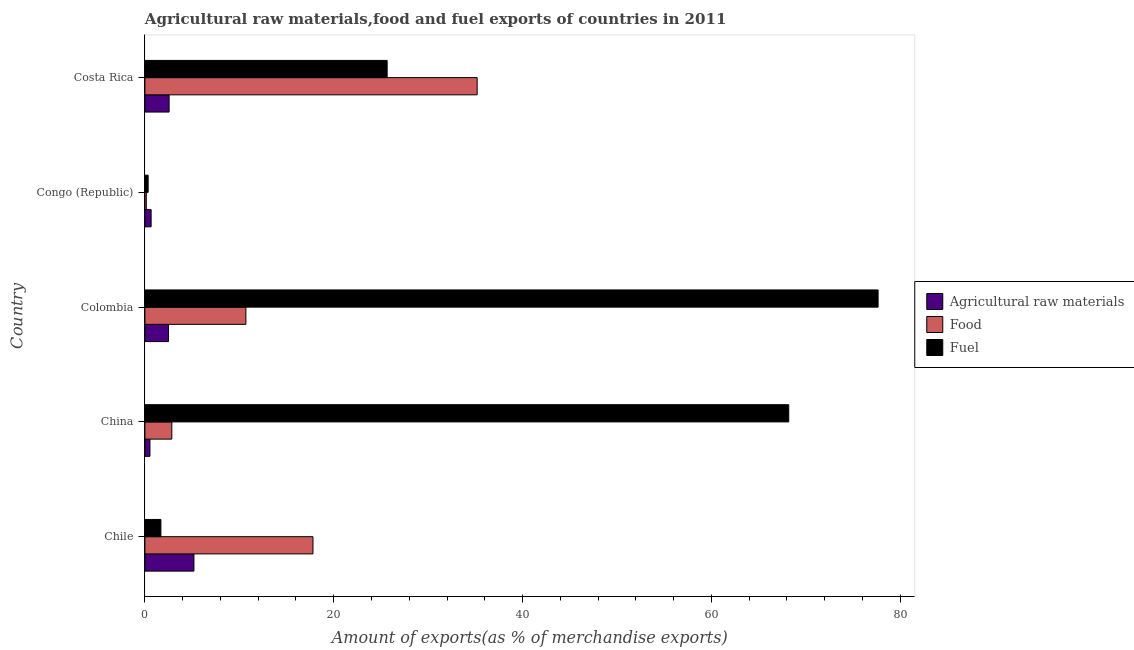How many groups of bars are there?
Ensure brevity in your answer.  5. Are the number of bars on each tick of the Y-axis equal?
Offer a terse response. Yes. How many bars are there on the 5th tick from the top?
Offer a terse response. 3. What is the label of the 1st group of bars from the top?
Ensure brevity in your answer.  Costa Rica. In how many cases, is the number of bars for a given country not equal to the number of legend labels?
Your answer should be very brief. 0. What is the percentage of raw materials exports in Costa Rica?
Keep it short and to the point. 2.56. Across all countries, what is the maximum percentage of fuel exports?
Your response must be concise. 77.67. Across all countries, what is the minimum percentage of fuel exports?
Your response must be concise. 0.34. In which country was the percentage of food exports minimum?
Make the answer very short. Congo (Republic). What is the total percentage of food exports in the graph?
Make the answer very short. 66.69. What is the difference between the percentage of raw materials exports in Chile and that in Congo (Republic)?
Offer a very short reply. 4.53. What is the difference between the percentage of fuel exports in Costa Rica and the percentage of raw materials exports in Chile?
Give a very brief answer. 20.47. What is the average percentage of fuel exports per country?
Give a very brief answer. 34.71. What is the difference between the percentage of fuel exports and percentage of raw materials exports in China?
Keep it short and to the point. 67.67. In how many countries, is the percentage of raw materials exports greater than 60 %?
Offer a very short reply. 0. What is the ratio of the percentage of raw materials exports in China to that in Congo (Republic)?
Your answer should be very brief. 0.81. Is the percentage of raw materials exports in Chile less than that in China?
Offer a terse response. No. Is the difference between the percentage of fuel exports in Chile and China greater than the difference between the percentage of food exports in Chile and China?
Provide a succinct answer. No. What is the difference between the highest and the second highest percentage of food exports?
Your answer should be compact. 17.39. What is the difference between the highest and the lowest percentage of raw materials exports?
Your response must be concise. 4.66. In how many countries, is the percentage of fuel exports greater than the average percentage of fuel exports taken over all countries?
Give a very brief answer. 2. Is the sum of the percentage of raw materials exports in Colombia and Costa Rica greater than the maximum percentage of fuel exports across all countries?
Your answer should be compact. No. What does the 3rd bar from the top in Chile represents?
Provide a short and direct response. Agricultural raw materials. What does the 2nd bar from the bottom in Colombia represents?
Offer a terse response. Food. Is it the case that in every country, the sum of the percentage of raw materials exports and percentage of food exports is greater than the percentage of fuel exports?
Make the answer very short. No. How many bars are there?
Ensure brevity in your answer.  15. How many countries are there in the graph?
Your response must be concise. 5. What is the difference between two consecutive major ticks on the X-axis?
Offer a very short reply. 20. Does the graph contain grids?
Keep it short and to the point. No. Where does the legend appear in the graph?
Give a very brief answer. Center right. How are the legend labels stacked?
Keep it short and to the point. Vertical. What is the title of the graph?
Provide a short and direct response. Agricultural raw materials,food and fuel exports of countries in 2011. What is the label or title of the X-axis?
Provide a short and direct response. Amount of exports(as % of merchandise exports). What is the label or title of the Y-axis?
Make the answer very short. Country. What is the Amount of exports(as % of merchandise exports) of Agricultural raw materials in Chile?
Provide a succinct answer. 5.19. What is the Amount of exports(as % of merchandise exports) of Food in Chile?
Keep it short and to the point. 17.8. What is the Amount of exports(as % of merchandise exports) in Fuel in Chile?
Ensure brevity in your answer.  1.69. What is the Amount of exports(as % of merchandise exports) of Agricultural raw materials in China?
Keep it short and to the point. 0.53. What is the Amount of exports(as % of merchandise exports) of Food in China?
Provide a succinct answer. 2.85. What is the Amount of exports(as % of merchandise exports) of Fuel in China?
Provide a succinct answer. 68.2. What is the Amount of exports(as % of merchandise exports) in Agricultural raw materials in Colombia?
Provide a short and direct response. 2.5. What is the Amount of exports(as % of merchandise exports) of Food in Colombia?
Your response must be concise. 10.7. What is the Amount of exports(as % of merchandise exports) of Fuel in Colombia?
Offer a very short reply. 77.67. What is the Amount of exports(as % of merchandise exports) of Agricultural raw materials in Congo (Republic)?
Ensure brevity in your answer.  0.66. What is the Amount of exports(as % of merchandise exports) in Food in Congo (Republic)?
Offer a very short reply. 0.15. What is the Amount of exports(as % of merchandise exports) in Fuel in Congo (Republic)?
Your response must be concise. 0.34. What is the Amount of exports(as % of merchandise exports) of Agricultural raw materials in Costa Rica?
Make the answer very short. 2.56. What is the Amount of exports(as % of merchandise exports) in Food in Costa Rica?
Offer a terse response. 35.19. What is the Amount of exports(as % of merchandise exports) of Fuel in Costa Rica?
Offer a very short reply. 25.66. Across all countries, what is the maximum Amount of exports(as % of merchandise exports) of Agricultural raw materials?
Ensure brevity in your answer.  5.19. Across all countries, what is the maximum Amount of exports(as % of merchandise exports) of Food?
Your answer should be compact. 35.19. Across all countries, what is the maximum Amount of exports(as % of merchandise exports) of Fuel?
Keep it short and to the point. 77.67. Across all countries, what is the minimum Amount of exports(as % of merchandise exports) in Agricultural raw materials?
Keep it short and to the point. 0.53. Across all countries, what is the minimum Amount of exports(as % of merchandise exports) in Food?
Make the answer very short. 0.15. Across all countries, what is the minimum Amount of exports(as % of merchandise exports) of Fuel?
Provide a short and direct response. 0.34. What is the total Amount of exports(as % of merchandise exports) in Agricultural raw materials in the graph?
Offer a very short reply. 11.45. What is the total Amount of exports(as % of merchandise exports) of Food in the graph?
Your response must be concise. 66.69. What is the total Amount of exports(as % of merchandise exports) in Fuel in the graph?
Your answer should be very brief. 173.56. What is the difference between the Amount of exports(as % of merchandise exports) in Agricultural raw materials in Chile and that in China?
Keep it short and to the point. 4.66. What is the difference between the Amount of exports(as % of merchandise exports) of Food in Chile and that in China?
Provide a succinct answer. 14.95. What is the difference between the Amount of exports(as % of merchandise exports) in Fuel in Chile and that in China?
Ensure brevity in your answer.  -66.51. What is the difference between the Amount of exports(as % of merchandise exports) of Agricultural raw materials in Chile and that in Colombia?
Ensure brevity in your answer.  2.69. What is the difference between the Amount of exports(as % of merchandise exports) of Food in Chile and that in Colombia?
Your answer should be very brief. 7.11. What is the difference between the Amount of exports(as % of merchandise exports) in Fuel in Chile and that in Colombia?
Your response must be concise. -75.97. What is the difference between the Amount of exports(as % of merchandise exports) in Agricultural raw materials in Chile and that in Congo (Republic)?
Offer a very short reply. 4.53. What is the difference between the Amount of exports(as % of merchandise exports) in Food in Chile and that in Congo (Republic)?
Give a very brief answer. 17.65. What is the difference between the Amount of exports(as % of merchandise exports) in Fuel in Chile and that in Congo (Republic)?
Your answer should be very brief. 1.35. What is the difference between the Amount of exports(as % of merchandise exports) in Agricultural raw materials in Chile and that in Costa Rica?
Make the answer very short. 2.63. What is the difference between the Amount of exports(as % of merchandise exports) in Food in Chile and that in Costa Rica?
Offer a very short reply. -17.39. What is the difference between the Amount of exports(as % of merchandise exports) in Fuel in Chile and that in Costa Rica?
Offer a very short reply. -23.97. What is the difference between the Amount of exports(as % of merchandise exports) of Agricultural raw materials in China and that in Colombia?
Give a very brief answer. -1.97. What is the difference between the Amount of exports(as % of merchandise exports) in Food in China and that in Colombia?
Provide a short and direct response. -7.84. What is the difference between the Amount of exports(as % of merchandise exports) of Fuel in China and that in Colombia?
Your answer should be very brief. -9.46. What is the difference between the Amount of exports(as % of merchandise exports) in Agricultural raw materials in China and that in Congo (Republic)?
Offer a terse response. -0.12. What is the difference between the Amount of exports(as % of merchandise exports) in Food in China and that in Congo (Republic)?
Make the answer very short. 2.7. What is the difference between the Amount of exports(as % of merchandise exports) of Fuel in China and that in Congo (Republic)?
Your response must be concise. 67.86. What is the difference between the Amount of exports(as % of merchandise exports) of Agricultural raw materials in China and that in Costa Rica?
Your answer should be compact. -2.03. What is the difference between the Amount of exports(as % of merchandise exports) of Food in China and that in Costa Rica?
Give a very brief answer. -32.34. What is the difference between the Amount of exports(as % of merchandise exports) in Fuel in China and that in Costa Rica?
Provide a succinct answer. 42.54. What is the difference between the Amount of exports(as % of merchandise exports) in Agricultural raw materials in Colombia and that in Congo (Republic)?
Provide a succinct answer. 1.84. What is the difference between the Amount of exports(as % of merchandise exports) of Food in Colombia and that in Congo (Republic)?
Your response must be concise. 10.55. What is the difference between the Amount of exports(as % of merchandise exports) of Fuel in Colombia and that in Congo (Republic)?
Keep it short and to the point. 77.32. What is the difference between the Amount of exports(as % of merchandise exports) in Agricultural raw materials in Colombia and that in Costa Rica?
Your response must be concise. -0.06. What is the difference between the Amount of exports(as % of merchandise exports) of Food in Colombia and that in Costa Rica?
Provide a short and direct response. -24.5. What is the difference between the Amount of exports(as % of merchandise exports) in Fuel in Colombia and that in Costa Rica?
Offer a terse response. 52.01. What is the difference between the Amount of exports(as % of merchandise exports) in Agricultural raw materials in Congo (Republic) and that in Costa Rica?
Your response must be concise. -1.9. What is the difference between the Amount of exports(as % of merchandise exports) of Food in Congo (Republic) and that in Costa Rica?
Your response must be concise. -35.05. What is the difference between the Amount of exports(as % of merchandise exports) in Fuel in Congo (Republic) and that in Costa Rica?
Offer a very short reply. -25.32. What is the difference between the Amount of exports(as % of merchandise exports) of Agricultural raw materials in Chile and the Amount of exports(as % of merchandise exports) of Food in China?
Your answer should be very brief. 2.34. What is the difference between the Amount of exports(as % of merchandise exports) in Agricultural raw materials in Chile and the Amount of exports(as % of merchandise exports) in Fuel in China?
Ensure brevity in your answer.  -63.01. What is the difference between the Amount of exports(as % of merchandise exports) in Food in Chile and the Amount of exports(as % of merchandise exports) in Fuel in China?
Offer a terse response. -50.4. What is the difference between the Amount of exports(as % of merchandise exports) of Agricultural raw materials in Chile and the Amount of exports(as % of merchandise exports) of Food in Colombia?
Provide a short and direct response. -5.5. What is the difference between the Amount of exports(as % of merchandise exports) in Agricultural raw materials in Chile and the Amount of exports(as % of merchandise exports) in Fuel in Colombia?
Provide a succinct answer. -72.47. What is the difference between the Amount of exports(as % of merchandise exports) of Food in Chile and the Amount of exports(as % of merchandise exports) of Fuel in Colombia?
Offer a very short reply. -59.86. What is the difference between the Amount of exports(as % of merchandise exports) in Agricultural raw materials in Chile and the Amount of exports(as % of merchandise exports) in Food in Congo (Republic)?
Offer a very short reply. 5.05. What is the difference between the Amount of exports(as % of merchandise exports) of Agricultural raw materials in Chile and the Amount of exports(as % of merchandise exports) of Fuel in Congo (Republic)?
Offer a terse response. 4.85. What is the difference between the Amount of exports(as % of merchandise exports) of Food in Chile and the Amount of exports(as % of merchandise exports) of Fuel in Congo (Republic)?
Your answer should be compact. 17.46. What is the difference between the Amount of exports(as % of merchandise exports) in Agricultural raw materials in Chile and the Amount of exports(as % of merchandise exports) in Food in Costa Rica?
Give a very brief answer. -30. What is the difference between the Amount of exports(as % of merchandise exports) of Agricultural raw materials in Chile and the Amount of exports(as % of merchandise exports) of Fuel in Costa Rica?
Make the answer very short. -20.47. What is the difference between the Amount of exports(as % of merchandise exports) of Food in Chile and the Amount of exports(as % of merchandise exports) of Fuel in Costa Rica?
Your answer should be very brief. -7.86. What is the difference between the Amount of exports(as % of merchandise exports) in Agricultural raw materials in China and the Amount of exports(as % of merchandise exports) in Food in Colombia?
Provide a succinct answer. -10.16. What is the difference between the Amount of exports(as % of merchandise exports) of Agricultural raw materials in China and the Amount of exports(as % of merchandise exports) of Fuel in Colombia?
Give a very brief answer. -77.13. What is the difference between the Amount of exports(as % of merchandise exports) in Food in China and the Amount of exports(as % of merchandise exports) in Fuel in Colombia?
Your response must be concise. -74.82. What is the difference between the Amount of exports(as % of merchandise exports) of Agricultural raw materials in China and the Amount of exports(as % of merchandise exports) of Food in Congo (Republic)?
Provide a succinct answer. 0.39. What is the difference between the Amount of exports(as % of merchandise exports) in Agricultural raw materials in China and the Amount of exports(as % of merchandise exports) in Fuel in Congo (Republic)?
Keep it short and to the point. 0.19. What is the difference between the Amount of exports(as % of merchandise exports) of Food in China and the Amount of exports(as % of merchandise exports) of Fuel in Congo (Republic)?
Your answer should be compact. 2.51. What is the difference between the Amount of exports(as % of merchandise exports) of Agricultural raw materials in China and the Amount of exports(as % of merchandise exports) of Food in Costa Rica?
Your response must be concise. -34.66. What is the difference between the Amount of exports(as % of merchandise exports) of Agricultural raw materials in China and the Amount of exports(as % of merchandise exports) of Fuel in Costa Rica?
Make the answer very short. -25.13. What is the difference between the Amount of exports(as % of merchandise exports) of Food in China and the Amount of exports(as % of merchandise exports) of Fuel in Costa Rica?
Offer a terse response. -22.81. What is the difference between the Amount of exports(as % of merchandise exports) in Agricultural raw materials in Colombia and the Amount of exports(as % of merchandise exports) in Food in Congo (Republic)?
Offer a terse response. 2.35. What is the difference between the Amount of exports(as % of merchandise exports) of Agricultural raw materials in Colombia and the Amount of exports(as % of merchandise exports) of Fuel in Congo (Republic)?
Your response must be concise. 2.16. What is the difference between the Amount of exports(as % of merchandise exports) in Food in Colombia and the Amount of exports(as % of merchandise exports) in Fuel in Congo (Republic)?
Provide a succinct answer. 10.35. What is the difference between the Amount of exports(as % of merchandise exports) of Agricultural raw materials in Colombia and the Amount of exports(as % of merchandise exports) of Food in Costa Rica?
Provide a short and direct response. -32.69. What is the difference between the Amount of exports(as % of merchandise exports) in Agricultural raw materials in Colombia and the Amount of exports(as % of merchandise exports) in Fuel in Costa Rica?
Offer a very short reply. -23.16. What is the difference between the Amount of exports(as % of merchandise exports) in Food in Colombia and the Amount of exports(as % of merchandise exports) in Fuel in Costa Rica?
Your response must be concise. -14.96. What is the difference between the Amount of exports(as % of merchandise exports) of Agricultural raw materials in Congo (Republic) and the Amount of exports(as % of merchandise exports) of Food in Costa Rica?
Give a very brief answer. -34.54. What is the difference between the Amount of exports(as % of merchandise exports) of Agricultural raw materials in Congo (Republic) and the Amount of exports(as % of merchandise exports) of Fuel in Costa Rica?
Ensure brevity in your answer.  -25. What is the difference between the Amount of exports(as % of merchandise exports) of Food in Congo (Republic) and the Amount of exports(as % of merchandise exports) of Fuel in Costa Rica?
Give a very brief answer. -25.51. What is the average Amount of exports(as % of merchandise exports) of Agricultural raw materials per country?
Your answer should be compact. 2.29. What is the average Amount of exports(as % of merchandise exports) of Food per country?
Your response must be concise. 13.34. What is the average Amount of exports(as % of merchandise exports) of Fuel per country?
Offer a very short reply. 34.71. What is the difference between the Amount of exports(as % of merchandise exports) of Agricultural raw materials and Amount of exports(as % of merchandise exports) of Food in Chile?
Provide a succinct answer. -12.61. What is the difference between the Amount of exports(as % of merchandise exports) of Agricultural raw materials and Amount of exports(as % of merchandise exports) of Fuel in Chile?
Keep it short and to the point. 3.5. What is the difference between the Amount of exports(as % of merchandise exports) in Food and Amount of exports(as % of merchandise exports) in Fuel in Chile?
Provide a succinct answer. 16.11. What is the difference between the Amount of exports(as % of merchandise exports) in Agricultural raw materials and Amount of exports(as % of merchandise exports) in Food in China?
Make the answer very short. -2.32. What is the difference between the Amount of exports(as % of merchandise exports) of Agricultural raw materials and Amount of exports(as % of merchandise exports) of Fuel in China?
Give a very brief answer. -67.67. What is the difference between the Amount of exports(as % of merchandise exports) of Food and Amount of exports(as % of merchandise exports) of Fuel in China?
Make the answer very short. -65.35. What is the difference between the Amount of exports(as % of merchandise exports) of Agricultural raw materials and Amount of exports(as % of merchandise exports) of Food in Colombia?
Keep it short and to the point. -8.2. What is the difference between the Amount of exports(as % of merchandise exports) in Agricultural raw materials and Amount of exports(as % of merchandise exports) in Fuel in Colombia?
Offer a terse response. -75.17. What is the difference between the Amount of exports(as % of merchandise exports) in Food and Amount of exports(as % of merchandise exports) in Fuel in Colombia?
Your answer should be compact. -66.97. What is the difference between the Amount of exports(as % of merchandise exports) in Agricultural raw materials and Amount of exports(as % of merchandise exports) in Food in Congo (Republic)?
Give a very brief answer. 0.51. What is the difference between the Amount of exports(as % of merchandise exports) of Agricultural raw materials and Amount of exports(as % of merchandise exports) of Fuel in Congo (Republic)?
Ensure brevity in your answer.  0.32. What is the difference between the Amount of exports(as % of merchandise exports) of Food and Amount of exports(as % of merchandise exports) of Fuel in Congo (Republic)?
Make the answer very short. -0.2. What is the difference between the Amount of exports(as % of merchandise exports) in Agricultural raw materials and Amount of exports(as % of merchandise exports) in Food in Costa Rica?
Provide a short and direct response. -32.63. What is the difference between the Amount of exports(as % of merchandise exports) in Agricultural raw materials and Amount of exports(as % of merchandise exports) in Fuel in Costa Rica?
Your answer should be compact. -23.1. What is the difference between the Amount of exports(as % of merchandise exports) of Food and Amount of exports(as % of merchandise exports) of Fuel in Costa Rica?
Ensure brevity in your answer.  9.53. What is the ratio of the Amount of exports(as % of merchandise exports) in Agricultural raw materials in Chile to that in China?
Offer a terse response. 9.73. What is the ratio of the Amount of exports(as % of merchandise exports) of Food in Chile to that in China?
Keep it short and to the point. 6.24. What is the ratio of the Amount of exports(as % of merchandise exports) in Fuel in Chile to that in China?
Provide a short and direct response. 0.02. What is the ratio of the Amount of exports(as % of merchandise exports) of Agricultural raw materials in Chile to that in Colombia?
Your answer should be very brief. 2.08. What is the ratio of the Amount of exports(as % of merchandise exports) of Food in Chile to that in Colombia?
Make the answer very short. 1.66. What is the ratio of the Amount of exports(as % of merchandise exports) of Fuel in Chile to that in Colombia?
Keep it short and to the point. 0.02. What is the ratio of the Amount of exports(as % of merchandise exports) of Agricultural raw materials in Chile to that in Congo (Republic)?
Give a very brief answer. 7.89. What is the ratio of the Amount of exports(as % of merchandise exports) in Food in Chile to that in Congo (Republic)?
Your answer should be compact. 121.22. What is the ratio of the Amount of exports(as % of merchandise exports) in Fuel in Chile to that in Congo (Republic)?
Make the answer very short. 4.95. What is the ratio of the Amount of exports(as % of merchandise exports) in Agricultural raw materials in Chile to that in Costa Rica?
Make the answer very short. 2.03. What is the ratio of the Amount of exports(as % of merchandise exports) of Food in Chile to that in Costa Rica?
Provide a succinct answer. 0.51. What is the ratio of the Amount of exports(as % of merchandise exports) in Fuel in Chile to that in Costa Rica?
Your answer should be very brief. 0.07. What is the ratio of the Amount of exports(as % of merchandise exports) in Agricultural raw materials in China to that in Colombia?
Provide a succinct answer. 0.21. What is the ratio of the Amount of exports(as % of merchandise exports) in Food in China to that in Colombia?
Offer a terse response. 0.27. What is the ratio of the Amount of exports(as % of merchandise exports) of Fuel in China to that in Colombia?
Ensure brevity in your answer.  0.88. What is the ratio of the Amount of exports(as % of merchandise exports) of Agricultural raw materials in China to that in Congo (Republic)?
Make the answer very short. 0.81. What is the ratio of the Amount of exports(as % of merchandise exports) in Food in China to that in Congo (Republic)?
Provide a short and direct response. 19.41. What is the ratio of the Amount of exports(as % of merchandise exports) in Fuel in China to that in Congo (Republic)?
Provide a succinct answer. 199.41. What is the ratio of the Amount of exports(as % of merchandise exports) of Agricultural raw materials in China to that in Costa Rica?
Keep it short and to the point. 0.21. What is the ratio of the Amount of exports(as % of merchandise exports) in Food in China to that in Costa Rica?
Provide a succinct answer. 0.08. What is the ratio of the Amount of exports(as % of merchandise exports) of Fuel in China to that in Costa Rica?
Offer a very short reply. 2.66. What is the ratio of the Amount of exports(as % of merchandise exports) in Agricultural raw materials in Colombia to that in Congo (Republic)?
Offer a terse response. 3.8. What is the ratio of the Amount of exports(as % of merchandise exports) of Food in Colombia to that in Congo (Republic)?
Make the answer very short. 72.83. What is the ratio of the Amount of exports(as % of merchandise exports) of Fuel in Colombia to that in Congo (Republic)?
Offer a very short reply. 227.08. What is the ratio of the Amount of exports(as % of merchandise exports) in Agricultural raw materials in Colombia to that in Costa Rica?
Offer a very short reply. 0.98. What is the ratio of the Amount of exports(as % of merchandise exports) of Food in Colombia to that in Costa Rica?
Your answer should be compact. 0.3. What is the ratio of the Amount of exports(as % of merchandise exports) in Fuel in Colombia to that in Costa Rica?
Your answer should be compact. 3.03. What is the ratio of the Amount of exports(as % of merchandise exports) in Agricultural raw materials in Congo (Republic) to that in Costa Rica?
Your answer should be very brief. 0.26. What is the ratio of the Amount of exports(as % of merchandise exports) of Food in Congo (Republic) to that in Costa Rica?
Your answer should be very brief. 0. What is the ratio of the Amount of exports(as % of merchandise exports) of Fuel in Congo (Republic) to that in Costa Rica?
Ensure brevity in your answer.  0.01. What is the difference between the highest and the second highest Amount of exports(as % of merchandise exports) in Agricultural raw materials?
Provide a short and direct response. 2.63. What is the difference between the highest and the second highest Amount of exports(as % of merchandise exports) in Food?
Give a very brief answer. 17.39. What is the difference between the highest and the second highest Amount of exports(as % of merchandise exports) of Fuel?
Your response must be concise. 9.46. What is the difference between the highest and the lowest Amount of exports(as % of merchandise exports) in Agricultural raw materials?
Ensure brevity in your answer.  4.66. What is the difference between the highest and the lowest Amount of exports(as % of merchandise exports) in Food?
Offer a terse response. 35.05. What is the difference between the highest and the lowest Amount of exports(as % of merchandise exports) of Fuel?
Give a very brief answer. 77.32. 